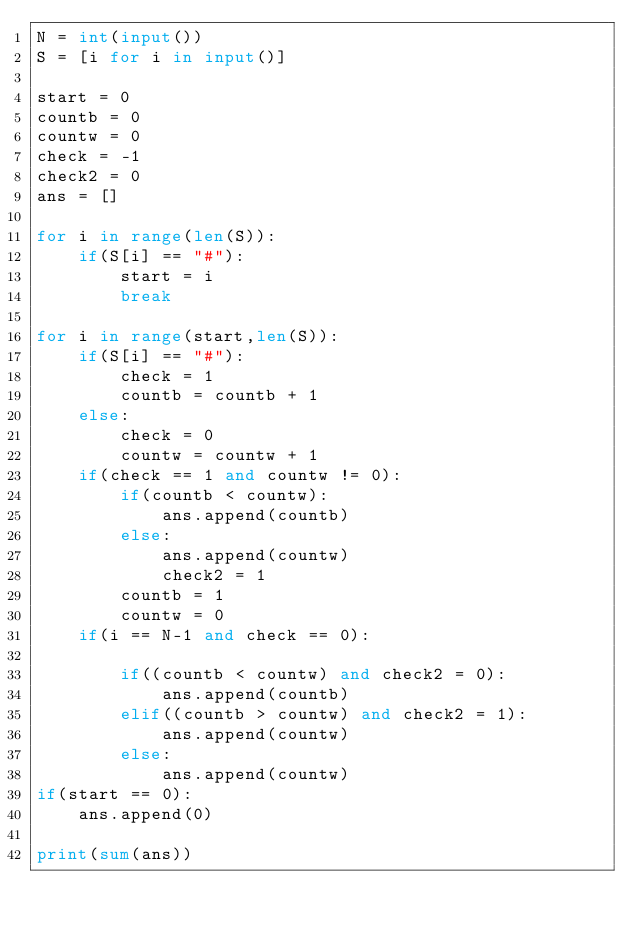Convert code to text. <code><loc_0><loc_0><loc_500><loc_500><_Python_>N = int(input())
S = [i for i in input()]

start = 0
countb = 0
countw = 0
check = -1
check2 = 0
ans = []

for i in range(len(S)):
    if(S[i] == "#"):
        start = i
        break

for i in range(start,len(S)):
    if(S[i] == "#"):
        check = 1
        countb = countb + 1
    else:
        check = 0
        countw = countw + 1
    if(check == 1 and countw != 0):
        if(countb < countw):
            ans.append(countb)
        else:
            ans.append(countw)
            check2 = 1
        countb = 1
        countw = 0
    if(i == N-1 and check == 0):
        
        if((countb < countw) and check2 = 0):
            ans.append(countb)
        elif((countb > countw) and check2 = 1):
            ans.append(countw)
        else:
            ans.append(countw)
if(start == 0):
    ans.append(0)

print(sum(ans))</code> 